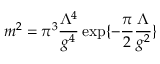<formula> <loc_0><loc_0><loc_500><loc_500>m ^ { 2 } = \pi ^ { 3 } \frac { \Lambda ^ { 4 } } { g ^ { 4 } } \exp \{ - \frac { \pi } { 2 } \frac { \Lambda } { g ^ { 2 } } \}</formula> 